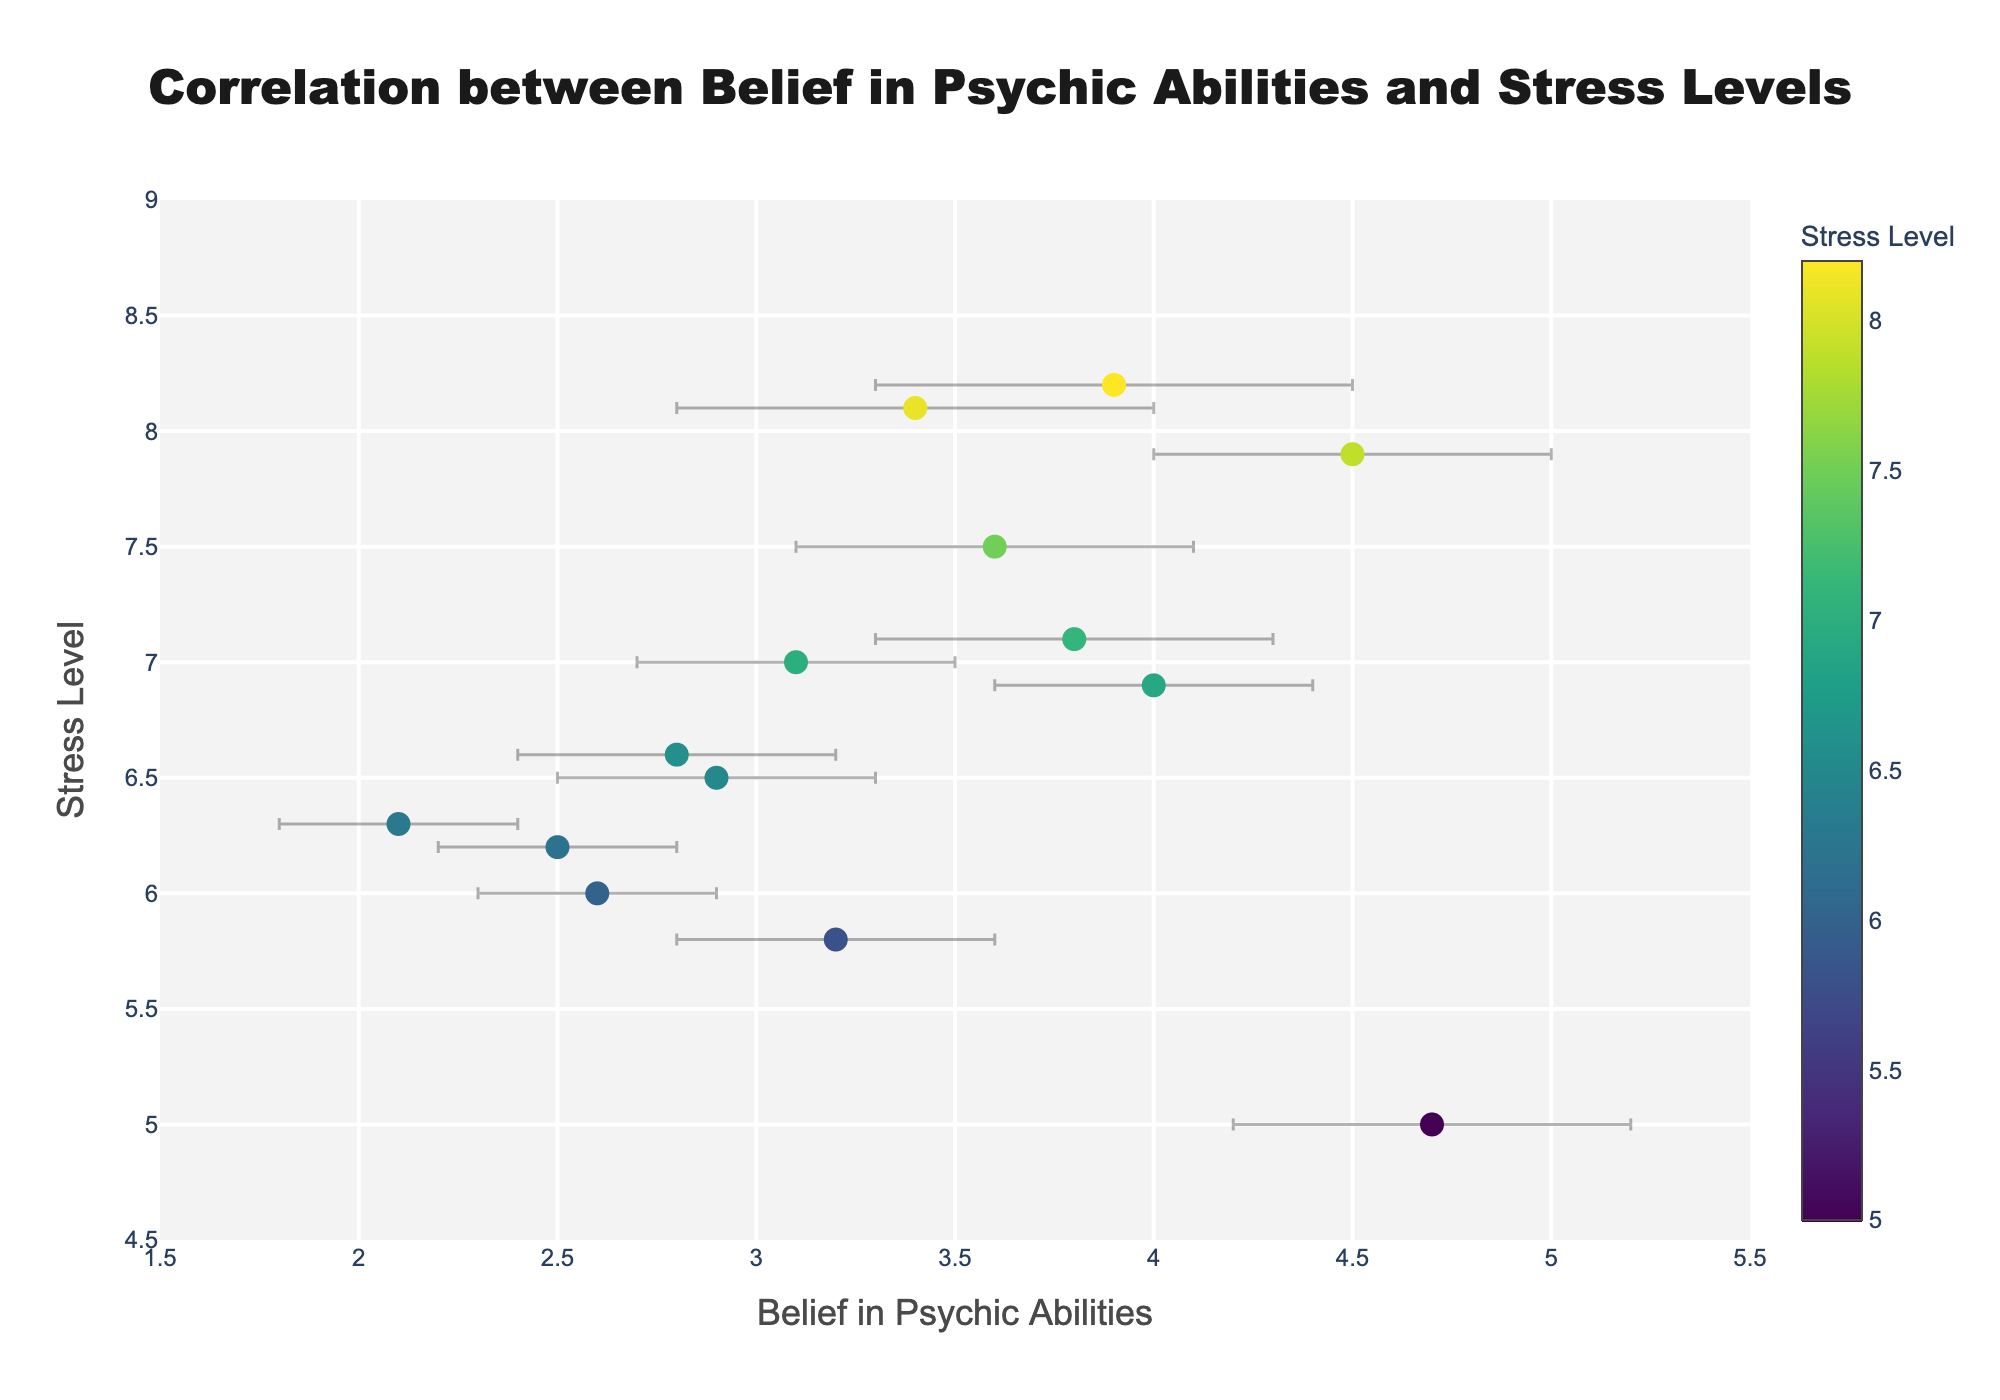Which occupation shows the highest stress level? Looking at the scatter plot, the point representing the Police Officer has the highest y-coordinate, which is near 8.2.
Answer: Police Officer What is the title of the figure? The title is located at the top center of the figure and is clearly labeled.
Answer: Correlation between Belief in Psychic Abilities and Stress Levels How many occupations are represented in the scatter plot? Each data point represents a different occupation. Counting them, there are 14 distinct data points.
Answer: 14 Which two occupations have similar belief in psychic abilities but different stress levels? By observing the x-axis for similar values and comparing their y-coordinates, Nurses (4.5 belief, 7.9 stress) and Artists (4.7 belief, 5.0 stress) fit this criterion.
Answer: Nurse and Artist What is the average stress level for occupations with a belief in psychic abilities greater than 3.5? The occupations fitting the criterion are Nurse (7.9), Police Officer (8.2), Retail Worker (6.9), Artist (5.0), Journalist (7.1), Doctor (8.1), and Restaurant Manager (7.5). Summing their stress levels: 7.9 + 8.2 + 6.9 + 5.0 + 7.1 + 8.1 + 7.5 = 50.7. Divide by 7 (the number of occupations): 50.7/7 ≈ 7.24.
Answer: Approximately 7.24 Which occupation has the largest error bar in belief in psychic abilities? By examining the horizontal error bars, the Police Officer's error bar seems the largest.
Answer: Police Officer Is there an outlier in terms of stress level compared to the trend line? Looking at the scatter plot, most points fit a general upward trend, but the Artist has a notably lower stress level compared to its high belief in psychic abilities, making it an outlier.
Answer: Artist 